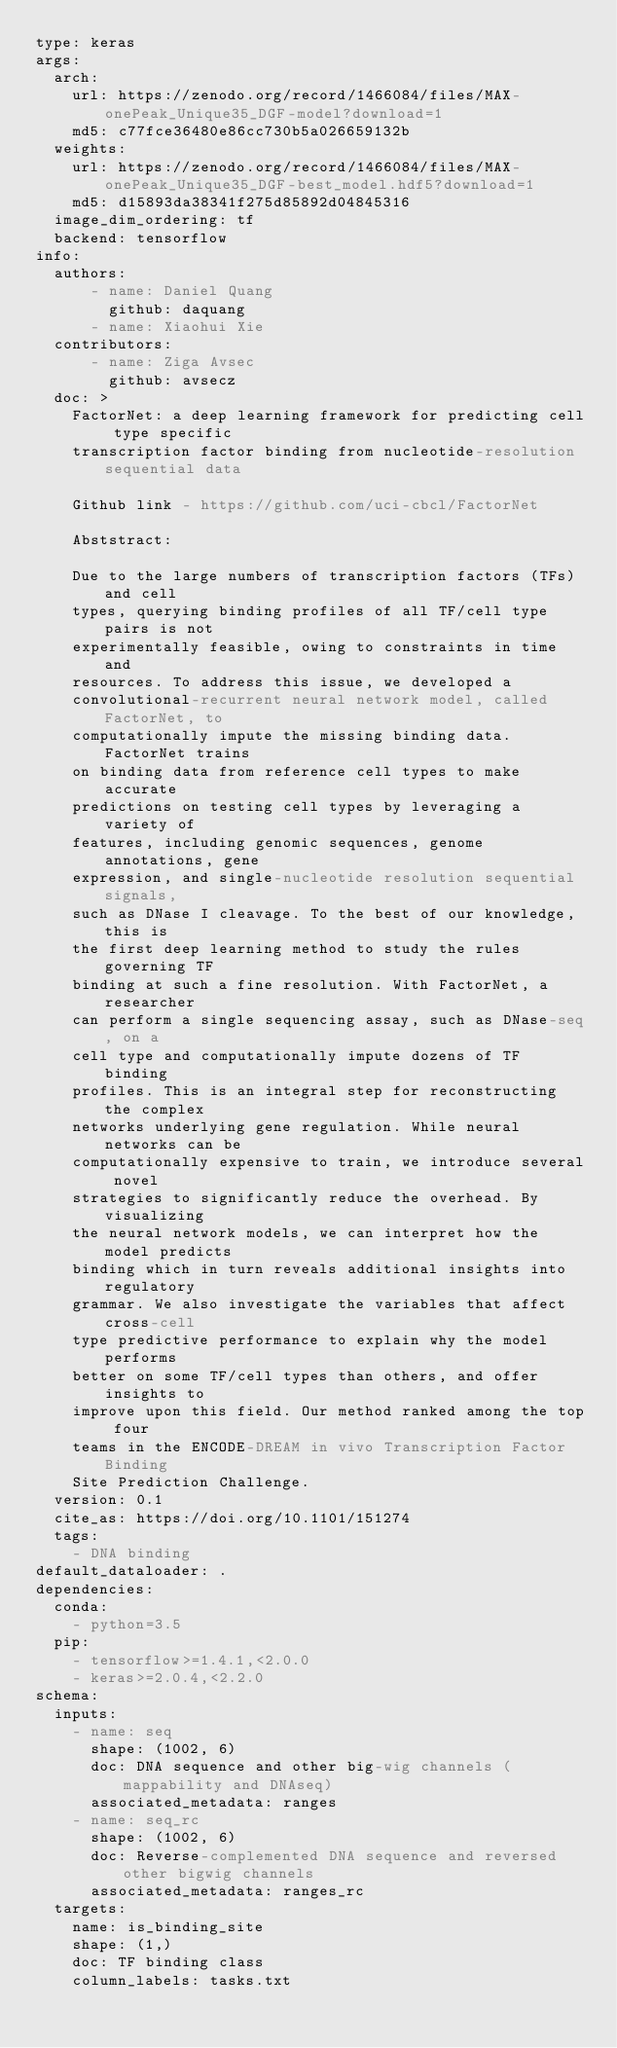<code> <loc_0><loc_0><loc_500><loc_500><_YAML_>type: keras
args:
  arch:
    url: https://zenodo.org/record/1466084/files/MAX-onePeak_Unique35_DGF-model?download=1
    md5: c77fce36480e86cc730b5a026659132b
  weights:
    url: https://zenodo.org/record/1466084/files/MAX-onePeak_Unique35_DGF-best_model.hdf5?download=1
    md5: d15893da38341f275d85892d04845316
  image_dim_ordering: tf
  backend: tensorflow
info:
  authors:
      - name: Daniel Quang
        github: daquang
      - name: Xiaohui Xie
  contributors:
      - name: Ziga Avsec
        github: avsecz
  doc: >
    FactorNet: a deep learning framework for predicting cell type specific
    transcription factor binding from nucleotide-resolution sequential data
  
    Github link - https://github.com/uci-cbcl/FactorNet

    Abststract:
    
    Due to the large numbers of transcription factors (TFs) and cell
    types, querying binding profiles of all TF/cell type pairs is not
    experimentally feasible, owing to constraints in time and
    resources. To address this issue, we developed a
    convolutional-recurrent neural network model, called FactorNet, to
    computationally impute the missing binding data. FactorNet trains
    on binding data from reference cell types to make accurate
    predictions on testing cell types by leveraging a variety of
    features, including genomic sequences, genome annotations, gene
    expression, and single-nucleotide resolution sequential signals,
    such as DNase I cleavage. To the best of our knowledge, this is
    the first deep learning method to study the rules governing TF
    binding at such a fine resolution. With FactorNet, a researcher
    can perform a single sequencing assay, such as DNase-seq, on a
    cell type and computationally impute dozens of TF binding
    profiles. This is an integral step for reconstructing the complex
    networks underlying gene regulation. While neural networks can be
    computationally expensive to train, we introduce several novel
    strategies to significantly reduce the overhead. By visualizing
    the neural network models, we can interpret how the model predicts
    binding which in turn reveals additional insights into regulatory
    grammar. We also investigate the variables that affect cross-cell
    type predictive performance to explain why the model performs
    better on some TF/cell types than others, and offer insights to
    improve upon this field. Our method ranked among the top four
    teams in the ENCODE-DREAM in vivo Transcription Factor Binding
    Site Prediction Challenge.
  version: 0.1
  cite_as: https://doi.org/10.1101/151274
  tags:
    - DNA binding
default_dataloader: .
dependencies:
  conda:
    - python=3.5
  pip:
    - tensorflow>=1.4.1,<2.0.0
    - keras>=2.0.4,<2.2.0
schema:
  inputs:
    - name: seq
      shape: (1002, 6)
      doc: DNA sequence and other big-wig channels (mappability and DNAseq)
      associated_metadata: ranges
    - name: seq_rc
      shape: (1002, 6)
      doc: Reverse-complemented DNA sequence and reversed other bigwig channels
      associated_metadata: ranges_rc
  targets:
    name: is_binding_site
    shape: (1,)
    doc: TF binding class
    column_labels: tasks.txt</code> 